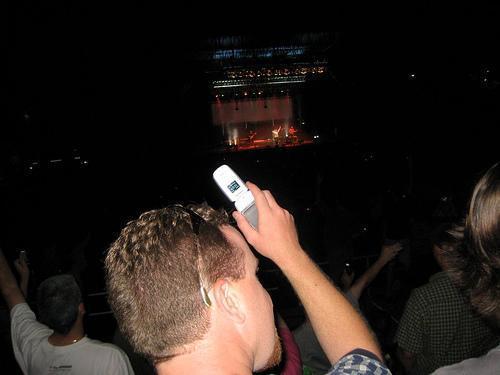How many people can be seen?
Give a very brief answer. 4. 